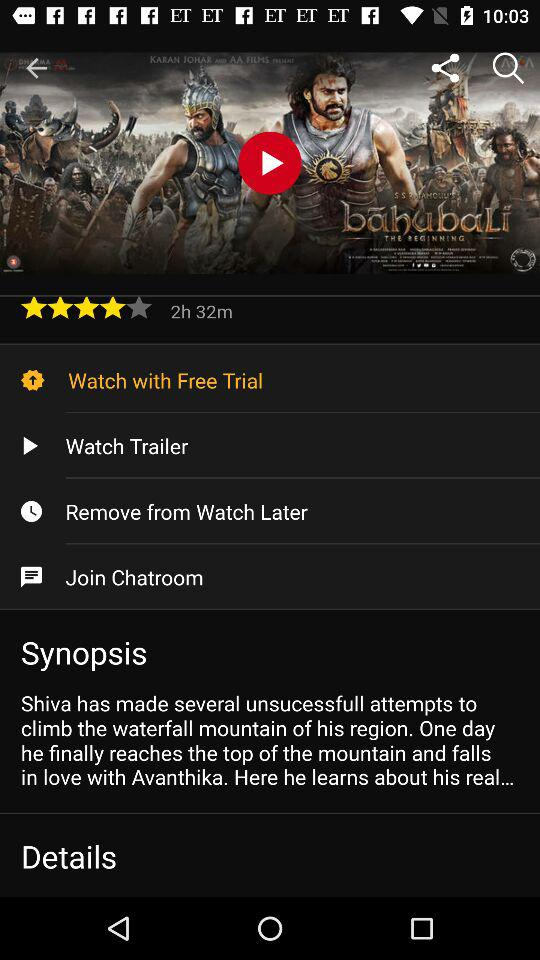How long is the movie? The movie is 2 hours and 32 minutes long. 